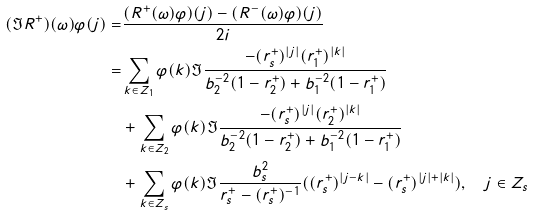<formula> <loc_0><loc_0><loc_500><loc_500>( \Im R ^ { + } ) ( \omega ) \varphi ( j ) = & \frac { ( R ^ { + } ( \omega ) \varphi ) ( j ) - ( R ^ { - } ( \omega ) \varphi ) ( j ) } { 2 i } \\ = & \sum _ { k \in Z _ { 1 } } \varphi ( k ) \Im \frac { - ( r _ { s } ^ { + } ) ^ { | j | } ( r _ { 1 } ^ { + } ) ^ { | k | } } { b _ { 2 } ^ { - 2 } ( 1 - r ^ { + } _ { 2 } ) + b _ { 1 } ^ { - 2 } ( 1 - r ^ { + } _ { 1 } ) } \\ & + \sum _ { k \in Z _ { 2 } } \varphi ( k ) \Im \frac { - ( r _ { s } ^ { + } ) ^ { | j | } ( r _ { 2 } ^ { + } ) ^ { | k | } } { b _ { 2 } ^ { - 2 } ( 1 - r ^ { + } _ { 2 } ) + b _ { 1 } ^ { - 2 } ( 1 - r ^ { + } _ { 1 } ) } \\ & + \sum _ { k \in Z _ { s } } \varphi ( k ) \Im \frac { b _ { s } ^ { 2 } } { r _ { s } ^ { + } - ( r _ { s } ^ { + } ) ^ { - 1 } } ( ( r _ { s } ^ { + } ) ^ { | j - k | } - ( r _ { s } ^ { + } ) ^ { | j | + | k | } ) , \quad j \in Z _ { s }</formula> 